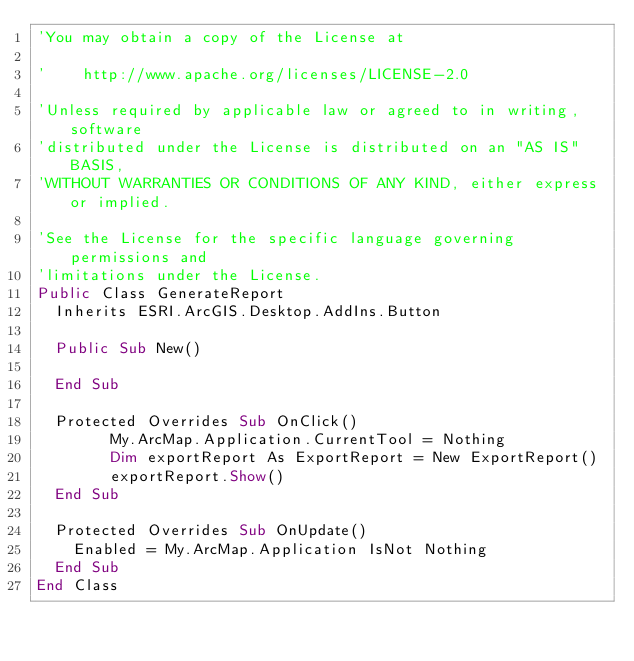Convert code to text. <code><loc_0><loc_0><loc_500><loc_500><_VisualBasic_>'You may obtain a copy of the License at

'    http://www.apache.org/licenses/LICENSE-2.0

'Unless required by applicable law or agreed to in writing, software
'distributed under the License is distributed on an "AS IS" BASIS,
'WITHOUT WARRANTIES OR CONDITIONS OF ANY KIND, either express or implied.

'See the License for the specific language governing permissions and
'limitations under the License.
Public Class GenerateReport
  Inherits ESRI.ArcGIS.Desktop.AddIns.Button

  Public Sub New()

  End Sub

  Protected Overrides Sub OnClick()
        My.ArcMap.Application.CurrentTool = Nothing
        Dim exportReport As ExportReport = New ExportReport()
        exportReport.Show()
  End Sub

  Protected Overrides Sub OnUpdate()
    Enabled = My.ArcMap.Application IsNot Nothing
  End Sub
End Class
</code> 